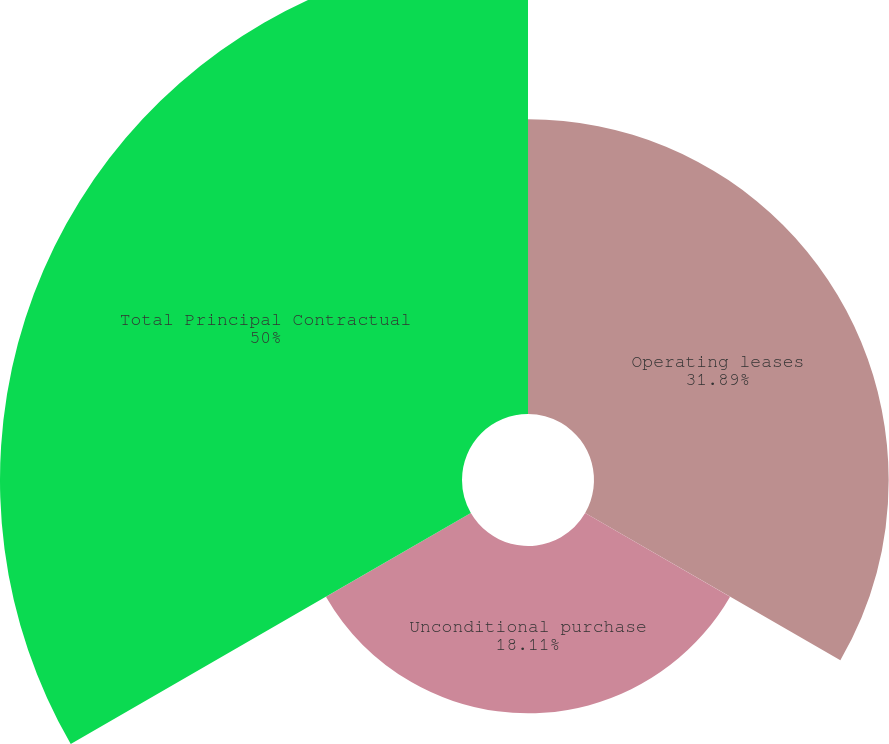<chart> <loc_0><loc_0><loc_500><loc_500><pie_chart><fcel>Operating leases<fcel>Unconditional purchase<fcel>Total Principal Contractual<nl><fcel>31.89%<fcel>18.11%<fcel>50.0%<nl></chart> 